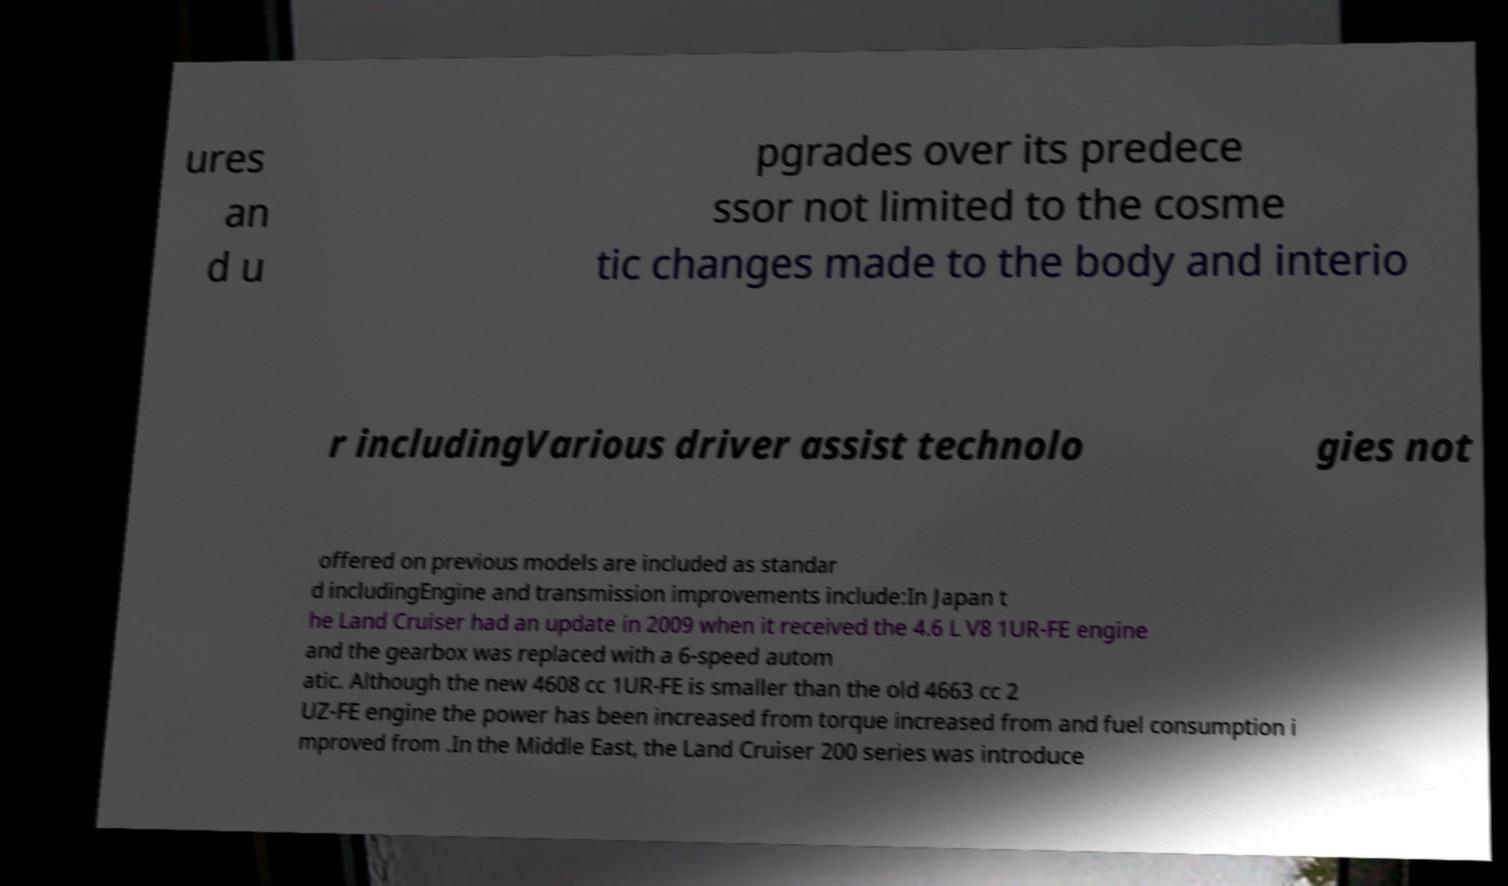Can you read and provide the text displayed in the image?This photo seems to have some interesting text. Can you extract and type it out for me? ures an d u pgrades over its predece ssor not limited to the cosme tic changes made to the body and interio r includingVarious driver assist technolo gies not offered on previous models are included as standar d includingEngine and transmission improvements include:In Japan t he Land Cruiser had an update in 2009 when it received the 4.6 L V8 1UR-FE engine and the gearbox was replaced with a 6-speed autom atic. Although the new 4608 cc 1UR-FE is smaller than the old 4663 cc 2 UZ-FE engine the power has been increased from torque increased from and fuel consumption i mproved from .In the Middle East, the Land Cruiser 200 series was introduce 